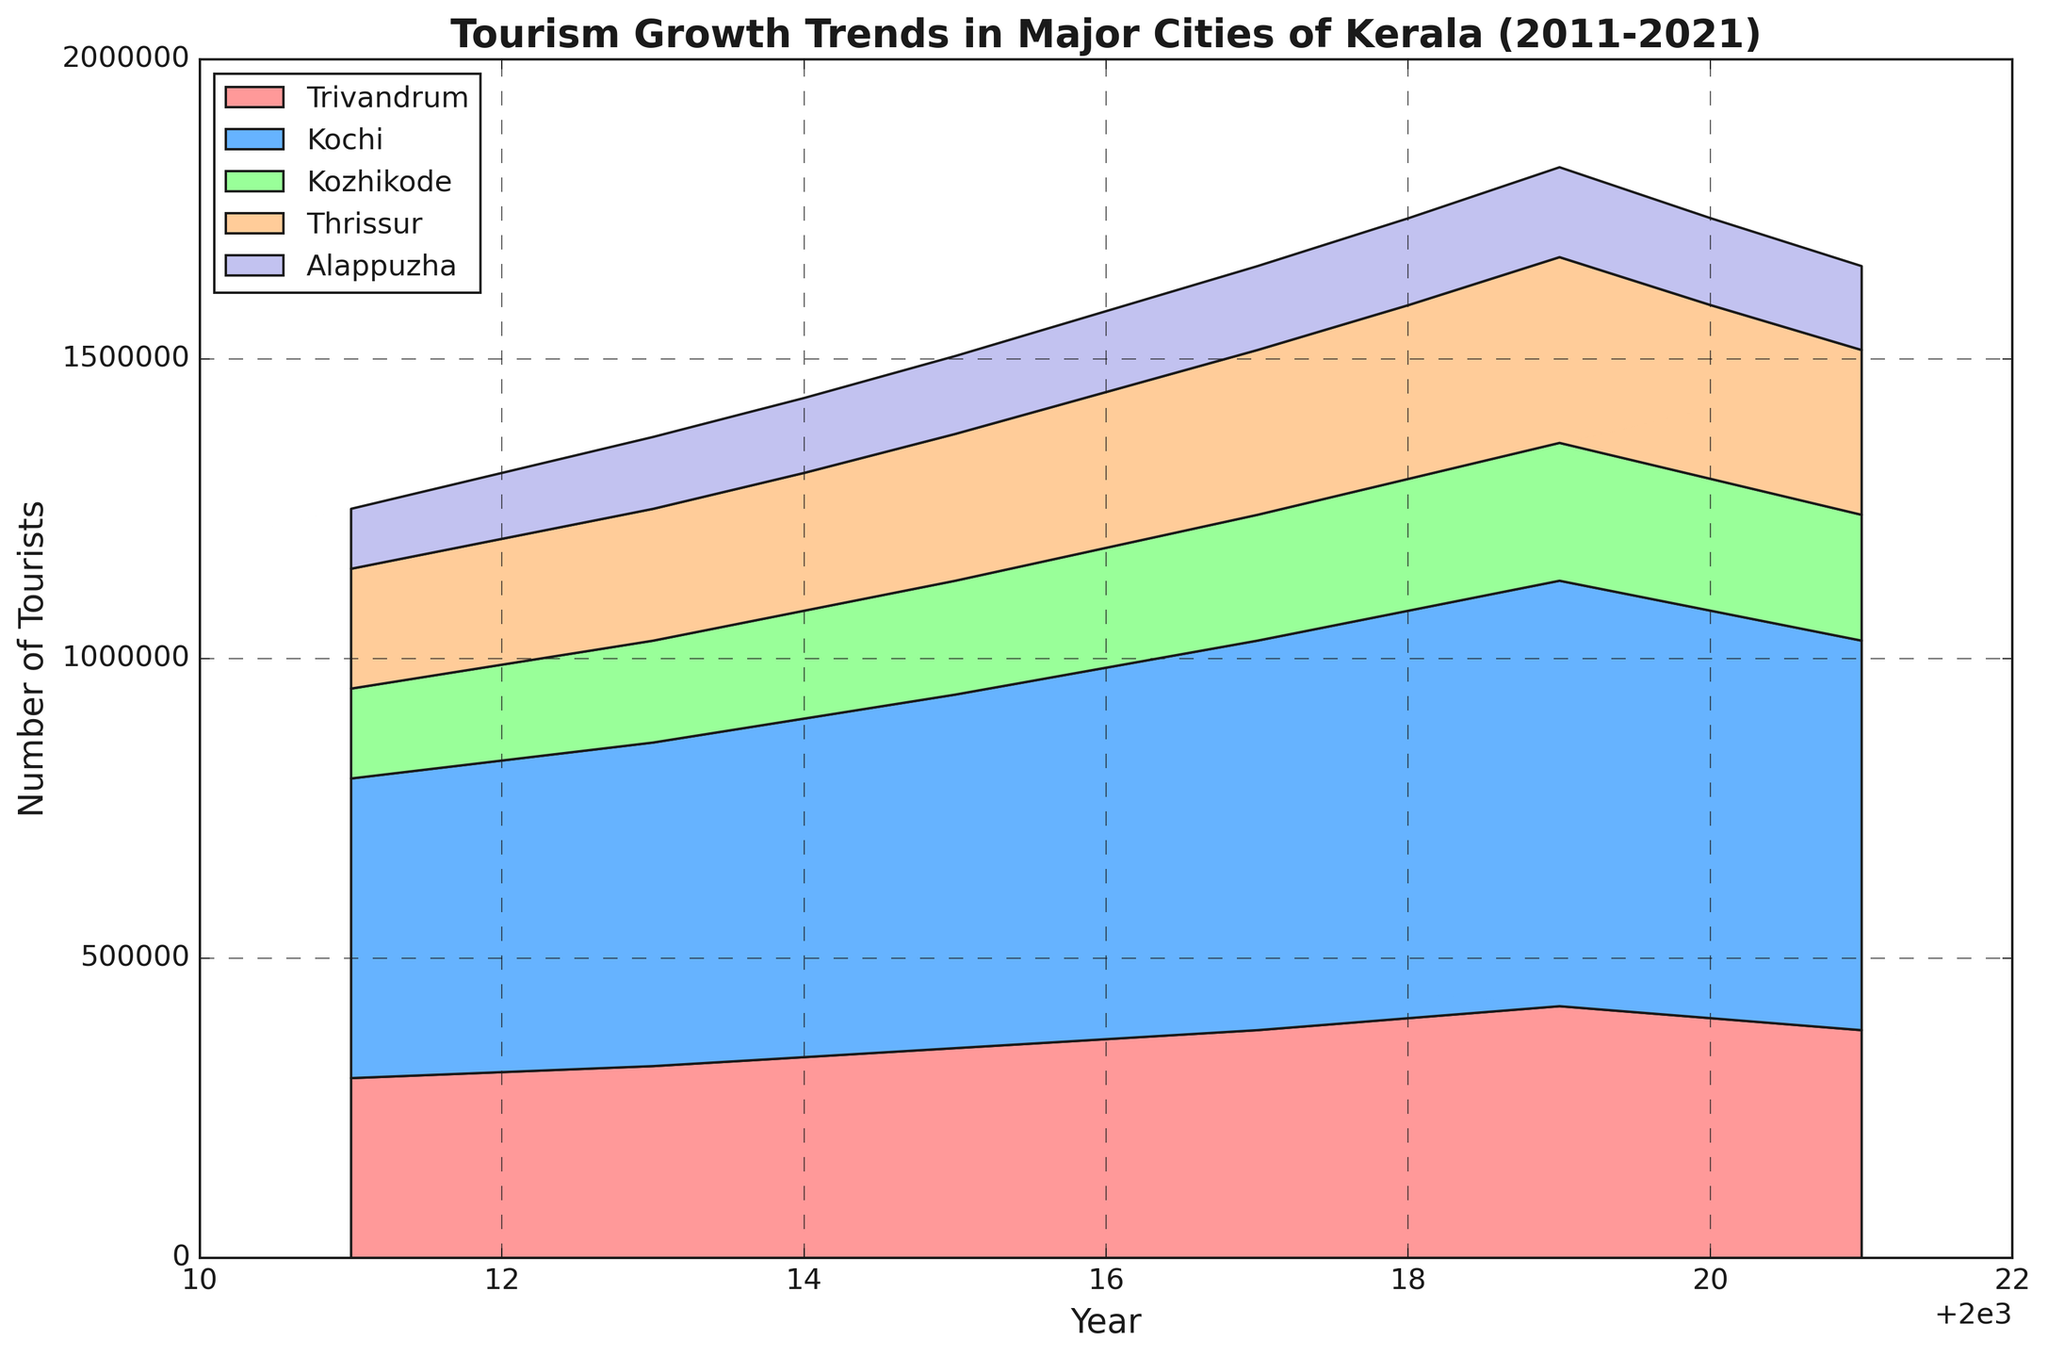What is the total number of tourists in Trivandrum and Kochi in 2015? Add the tourists in Trivandrum (350,000) and Kochi (590,000) for 2015
Answer: 940,000 Which city experienced the highest tourist growth in 2013? Check the increase in tourists from 2012 to 2013 for each city; Kochi had an increase of 20,000, which is the highest
Answer: Kochi Between which two years did Alappuzha experience the highest increase in tourists? Observe the differences in tourist numbers year by year for Alappuzha; the largest increase is from 2018 (145,000) to 2019 (150,000), which is 5,000
Answer: 2018-2019 Which city's area is most visually prominent for the year 2021? The width and filled areas for each city stack together, and the largest stacked area in 2021 is Kochi's
Answer: Kochi How many years did the tourist count in Trivandrum remain the same? Identify years with the same number; 2020 (400,000) and 2019 (400,000); no same counts identified, initial counts suggest it's a trick question
Answer: 0 What is the average number of tourists in Kozhikode between 2011 and 2021? Sum tourists from 2011 to 2021 for Kozhikode and divide by 11; sum is 2,200,000, average is 200,000
Answer: 200,000 Did Thrissur ever have more tourists than Trivandrum? Compare tourist counts each year; Trivandrum was always higher
Answer: No Which year saw the highest total number of tourists across all cities? Sum the tourists of all cities year by year, and 2019 has highest sum (1,910,000)
Answer: 2019 Are there any years where the tourist numbers decreased for more than one city? Look for years with declines; 2020 saw decreases for three cities: Trivandrum, Kochi, and Kozhikode
Answer: 2020 Which color represents the area for Alappuzha? Identify the color coding; Alappuzha is represented by purple (check legend)
Answer: Purple 